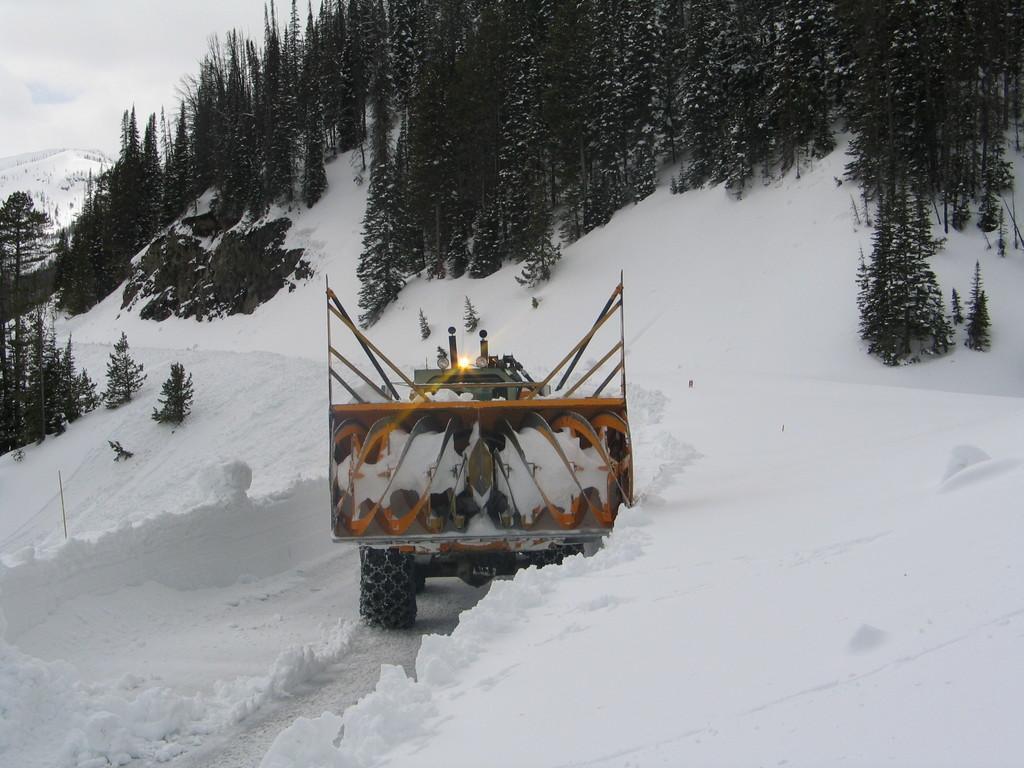Can you describe this image briefly? In this image it seems like there is a truck in the snow. In front of the truck there are trees which are covered with the snow. At the bottom there is snow. In the middle we can see a small light. 